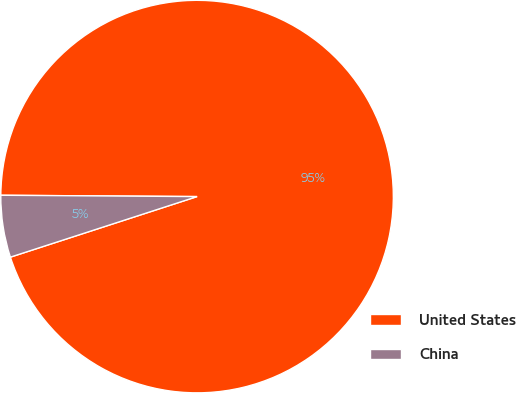Convert chart to OTSL. <chart><loc_0><loc_0><loc_500><loc_500><pie_chart><fcel>United States<fcel>China<nl><fcel>94.9%<fcel>5.1%<nl></chart> 